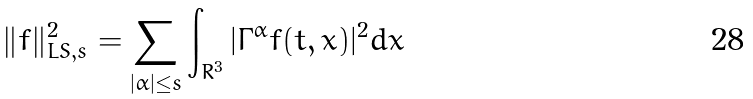<formula> <loc_0><loc_0><loc_500><loc_500>\| f \| _ { L S , s } ^ { 2 } = \sum _ { | \alpha | \leq s } \int _ { R ^ { 3 } } | \Gamma ^ { \alpha } f ( t , x ) | ^ { 2 } d x</formula> 